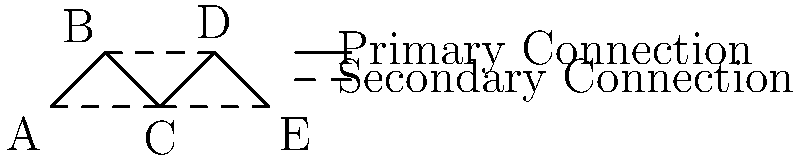In the healthcare information flow network diagram above, nodes represent different departments (A: Emergency, B: Radiology, C: Laboratory, D: Pharmacy, E: Inpatient), solid lines represent primary connections, and dashed lines represent secondary connections. If the primary connection between Laboratory (C) and Pharmacy (D) fails, what is the minimum number of secondary connections that need to be activated to maintain connectivity between all departments? To solve this problem, we need to follow these steps:

1. Identify the current primary connections:
   A-B, B-C, C-D, D-E

2. Identify the secondary connections:
   A-C, B-D, C-E

3. Remove the failed primary connection:
   C-D is removed

4. Analyze the remaining connectivity:
   - A, B, and C are still connected
   - D and E are still connected
   - But there's no connection between (A,B,C) and (D,E)

5. Find the minimum number of secondary connections to restore full connectivity:
   - We need to connect either C or B to either D or E
   - The available secondary connections that can do this are:
     B-D or C-E

6. Conclusion:
   Activating either B-D or C-E (one secondary connection) is sufficient to restore full connectivity.

Therefore, the minimum number of secondary connections that need to be activated is 1.
Answer: 1 